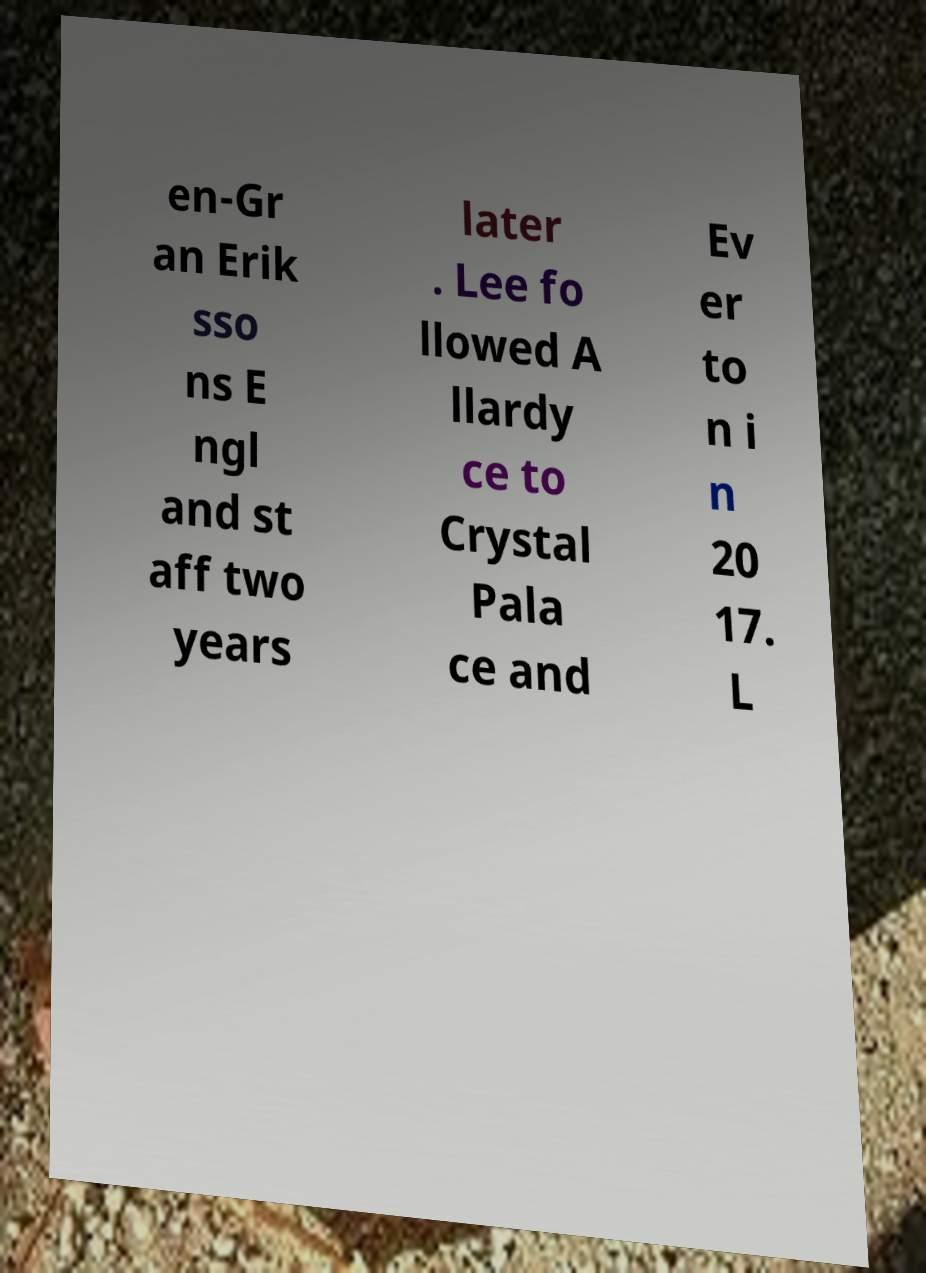For documentation purposes, I need the text within this image transcribed. Could you provide that? en-Gr an Erik sso ns E ngl and st aff two years later . Lee fo llowed A llardy ce to Crystal Pala ce and Ev er to n i n 20 17. L 